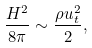Convert formula to latex. <formula><loc_0><loc_0><loc_500><loc_500>\frac { H ^ { 2 } } { 8 \pi } \sim \frac { \rho u _ { t } ^ { 2 } } { 2 } ,</formula> 